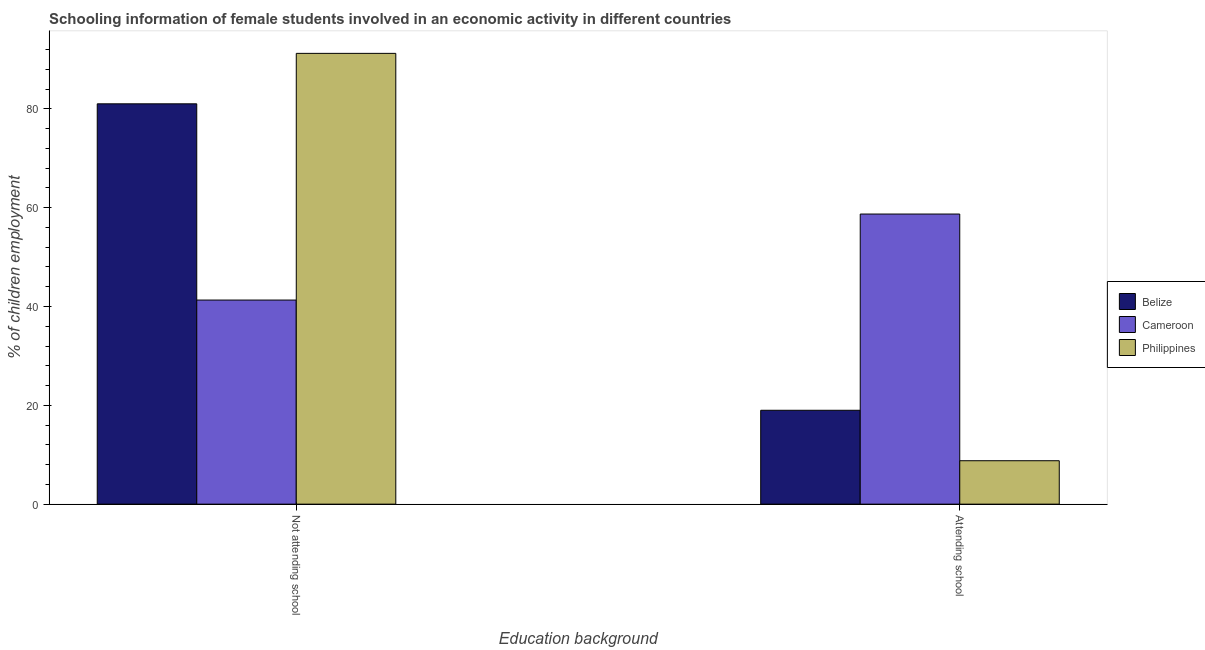How many different coloured bars are there?
Offer a very short reply. 3. How many bars are there on the 2nd tick from the right?
Your answer should be compact. 3. What is the label of the 2nd group of bars from the left?
Give a very brief answer. Attending school. What is the percentage of employed females who are attending school in Philippines?
Keep it short and to the point. 8.79. Across all countries, what is the maximum percentage of employed females who are not attending school?
Make the answer very short. 91.21. Across all countries, what is the minimum percentage of employed females who are not attending school?
Keep it short and to the point. 41.3. In which country was the percentage of employed females who are attending school minimum?
Provide a short and direct response. Philippines. What is the total percentage of employed females who are attending school in the graph?
Your answer should be very brief. 86.49. What is the difference between the percentage of employed females who are attending school in Philippines and that in Belize?
Your answer should be compact. -10.21. What is the difference between the percentage of employed females who are attending school in Belize and the percentage of employed females who are not attending school in Cameroon?
Keep it short and to the point. -22.3. What is the average percentage of employed females who are not attending school per country?
Keep it short and to the point. 71.17. What is the difference between the percentage of employed females who are attending school and percentage of employed females who are not attending school in Belize?
Keep it short and to the point. -62.01. In how many countries, is the percentage of employed females who are not attending school greater than 80 %?
Keep it short and to the point. 2. What is the ratio of the percentage of employed females who are not attending school in Belize to that in Cameroon?
Your answer should be very brief. 1.96. What does the 2nd bar from the left in Attending school represents?
Provide a succinct answer. Cameroon. What does the 1st bar from the right in Not attending school represents?
Your response must be concise. Philippines. How many bars are there?
Your answer should be compact. 6. Are all the bars in the graph horizontal?
Your response must be concise. No. How many countries are there in the graph?
Offer a very short reply. 3. Are the values on the major ticks of Y-axis written in scientific E-notation?
Keep it short and to the point. No. Where does the legend appear in the graph?
Your response must be concise. Center right. How many legend labels are there?
Keep it short and to the point. 3. What is the title of the graph?
Give a very brief answer. Schooling information of female students involved in an economic activity in different countries. Does "Fiji" appear as one of the legend labels in the graph?
Provide a succinct answer. No. What is the label or title of the X-axis?
Keep it short and to the point. Education background. What is the label or title of the Y-axis?
Give a very brief answer. % of children employment. What is the % of children employment in Belize in Not attending school?
Offer a very short reply. 81. What is the % of children employment of Cameroon in Not attending school?
Keep it short and to the point. 41.3. What is the % of children employment in Philippines in Not attending school?
Ensure brevity in your answer.  91.21. What is the % of children employment in Belize in Attending school?
Ensure brevity in your answer.  19. What is the % of children employment of Cameroon in Attending school?
Keep it short and to the point. 58.7. What is the % of children employment in Philippines in Attending school?
Ensure brevity in your answer.  8.79. Across all Education background, what is the maximum % of children employment of Belize?
Keep it short and to the point. 81. Across all Education background, what is the maximum % of children employment of Cameroon?
Provide a succinct answer. 58.7. Across all Education background, what is the maximum % of children employment in Philippines?
Provide a succinct answer. 91.21. Across all Education background, what is the minimum % of children employment in Belize?
Offer a terse response. 19. Across all Education background, what is the minimum % of children employment of Cameroon?
Make the answer very short. 41.3. Across all Education background, what is the minimum % of children employment of Philippines?
Your response must be concise. 8.79. What is the total % of children employment in Cameroon in the graph?
Provide a succinct answer. 100. What is the difference between the % of children employment in Belize in Not attending school and that in Attending school?
Give a very brief answer. 62.01. What is the difference between the % of children employment in Cameroon in Not attending school and that in Attending school?
Your answer should be very brief. -17.41. What is the difference between the % of children employment of Philippines in Not attending school and that in Attending school?
Your response must be concise. 82.43. What is the difference between the % of children employment of Belize in Not attending school and the % of children employment of Cameroon in Attending school?
Make the answer very short. 22.3. What is the difference between the % of children employment in Belize in Not attending school and the % of children employment in Philippines in Attending school?
Ensure brevity in your answer.  72.22. What is the difference between the % of children employment of Cameroon in Not attending school and the % of children employment of Philippines in Attending school?
Make the answer very short. 32.51. What is the average % of children employment in Cameroon per Education background?
Provide a succinct answer. 50. What is the difference between the % of children employment in Belize and % of children employment in Cameroon in Not attending school?
Keep it short and to the point. 39.71. What is the difference between the % of children employment in Belize and % of children employment in Philippines in Not attending school?
Ensure brevity in your answer.  -10.21. What is the difference between the % of children employment of Cameroon and % of children employment of Philippines in Not attending school?
Your response must be concise. -49.92. What is the difference between the % of children employment of Belize and % of children employment of Cameroon in Attending school?
Keep it short and to the point. -39.71. What is the difference between the % of children employment in Belize and % of children employment in Philippines in Attending school?
Give a very brief answer. 10.21. What is the difference between the % of children employment in Cameroon and % of children employment in Philippines in Attending school?
Your response must be concise. 49.92. What is the ratio of the % of children employment of Belize in Not attending school to that in Attending school?
Provide a succinct answer. 4.26. What is the ratio of the % of children employment of Cameroon in Not attending school to that in Attending school?
Ensure brevity in your answer.  0.7. What is the ratio of the % of children employment of Philippines in Not attending school to that in Attending school?
Give a very brief answer. 10.38. What is the difference between the highest and the second highest % of children employment of Belize?
Your answer should be very brief. 62.01. What is the difference between the highest and the second highest % of children employment in Cameroon?
Provide a short and direct response. 17.41. What is the difference between the highest and the second highest % of children employment of Philippines?
Ensure brevity in your answer.  82.43. What is the difference between the highest and the lowest % of children employment in Belize?
Provide a short and direct response. 62.01. What is the difference between the highest and the lowest % of children employment of Cameroon?
Offer a very short reply. 17.41. What is the difference between the highest and the lowest % of children employment in Philippines?
Offer a very short reply. 82.43. 